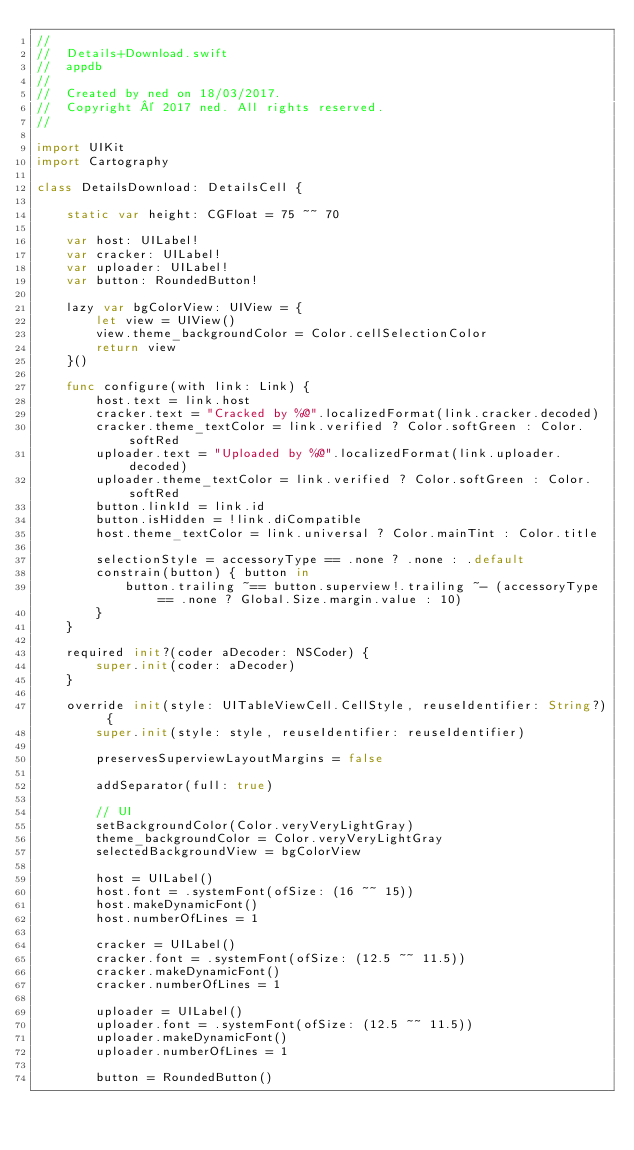<code> <loc_0><loc_0><loc_500><loc_500><_Swift_>//
//  Details+Download.swift
//  appdb
//
//  Created by ned on 18/03/2017.
//  Copyright © 2017 ned. All rights reserved.
//

import UIKit
import Cartography

class DetailsDownload: DetailsCell {

    static var height: CGFloat = 75 ~~ 70

    var host: UILabel!
    var cracker: UILabel!
    var uploader: UILabel!
    var button: RoundedButton!

    lazy var bgColorView: UIView = {
        let view = UIView()
        view.theme_backgroundColor = Color.cellSelectionColor
        return view
    }()

    func configure(with link: Link) {
        host.text = link.host
        cracker.text = "Cracked by %@".localizedFormat(link.cracker.decoded)
        cracker.theme_textColor = link.verified ? Color.softGreen : Color.softRed
        uploader.text = "Uploaded by %@".localizedFormat(link.uploader.decoded)
        uploader.theme_textColor = link.verified ? Color.softGreen : Color.softRed
        button.linkId = link.id
        button.isHidden = !link.diCompatible
        host.theme_textColor = link.universal ? Color.mainTint : Color.title

        selectionStyle = accessoryType == .none ? .none : .default
        constrain(button) { button in
            button.trailing ~== button.superview!.trailing ~- (accessoryType == .none ? Global.Size.margin.value : 10)
        }
    }

    required init?(coder aDecoder: NSCoder) {
        super.init(coder: aDecoder)
    }

    override init(style: UITableViewCell.CellStyle, reuseIdentifier: String?) {
        super.init(style: style, reuseIdentifier: reuseIdentifier)

        preservesSuperviewLayoutMargins = false

        addSeparator(full: true)

        // UI
        setBackgroundColor(Color.veryVeryLightGray)
        theme_backgroundColor = Color.veryVeryLightGray
        selectedBackgroundView = bgColorView

        host = UILabel()
        host.font = .systemFont(ofSize: (16 ~~ 15))
        host.makeDynamicFont()
        host.numberOfLines = 1

        cracker = UILabel()
        cracker.font = .systemFont(ofSize: (12.5 ~~ 11.5))
        cracker.makeDynamicFont()
        cracker.numberOfLines = 1

        uploader = UILabel()
        uploader.font = .systemFont(ofSize: (12.5 ~~ 11.5))
        uploader.makeDynamicFont()
        uploader.numberOfLines = 1

        button = RoundedButton()</code> 